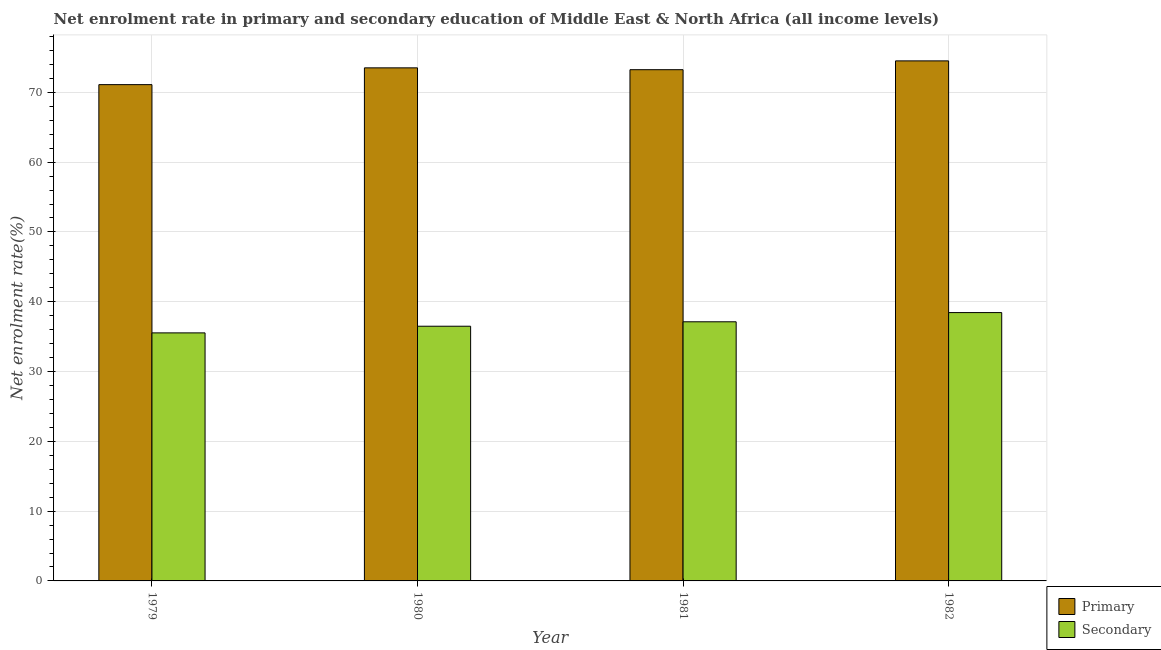How many groups of bars are there?
Make the answer very short. 4. Are the number of bars per tick equal to the number of legend labels?
Provide a succinct answer. Yes. In how many cases, is the number of bars for a given year not equal to the number of legend labels?
Offer a very short reply. 0. What is the enrollment rate in primary education in 1979?
Offer a terse response. 71.11. Across all years, what is the maximum enrollment rate in primary education?
Keep it short and to the point. 74.51. Across all years, what is the minimum enrollment rate in primary education?
Your response must be concise. 71.11. In which year was the enrollment rate in primary education minimum?
Keep it short and to the point. 1979. What is the total enrollment rate in secondary education in the graph?
Offer a very short reply. 147.6. What is the difference between the enrollment rate in primary education in 1979 and that in 1982?
Offer a very short reply. -3.4. What is the difference between the enrollment rate in secondary education in 1980 and the enrollment rate in primary education in 1982?
Ensure brevity in your answer.  -1.95. What is the average enrollment rate in primary education per year?
Give a very brief answer. 73.09. In how many years, is the enrollment rate in secondary education greater than 26 %?
Your response must be concise. 4. What is the ratio of the enrollment rate in secondary education in 1980 to that in 1981?
Make the answer very short. 0.98. What is the difference between the highest and the second highest enrollment rate in primary education?
Your response must be concise. 1. What is the difference between the highest and the lowest enrollment rate in secondary education?
Your answer should be compact. 2.91. What does the 2nd bar from the left in 1979 represents?
Offer a terse response. Secondary. What does the 1st bar from the right in 1979 represents?
Provide a short and direct response. Secondary. What is the difference between two consecutive major ticks on the Y-axis?
Keep it short and to the point. 10. How many legend labels are there?
Your answer should be compact. 2. How are the legend labels stacked?
Offer a very short reply. Vertical. What is the title of the graph?
Your response must be concise. Net enrolment rate in primary and secondary education of Middle East & North Africa (all income levels). What is the label or title of the Y-axis?
Make the answer very short. Net enrolment rate(%). What is the Net enrolment rate(%) in Primary in 1979?
Provide a short and direct response. 71.11. What is the Net enrolment rate(%) of Secondary in 1979?
Offer a very short reply. 35.54. What is the Net enrolment rate(%) of Primary in 1980?
Provide a succinct answer. 73.51. What is the Net enrolment rate(%) of Secondary in 1980?
Offer a terse response. 36.49. What is the Net enrolment rate(%) in Primary in 1981?
Keep it short and to the point. 73.25. What is the Net enrolment rate(%) of Secondary in 1981?
Your answer should be compact. 37.13. What is the Net enrolment rate(%) of Primary in 1982?
Your answer should be compact. 74.51. What is the Net enrolment rate(%) in Secondary in 1982?
Make the answer very short. 38.45. Across all years, what is the maximum Net enrolment rate(%) of Primary?
Keep it short and to the point. 74.51. Across all years, what is the maximum Net enrolment rate(%) of Secondary?
Provide a short and direct response. 38.45. Across all years, what is the minimum Net enrolment rate(%) in Primary?
Give a very brief answer. 71.11. Across all years, what is the minimum Net enrolment rate(%) in Secondary?
Your answer should be very brief. 35.54. What is the total Net enrolment rate(%) in Primary in the graph?
Make the answer very short. 292.37. What is the total Net enrolment rate(%) of Secondary in the graph?
Provide a short and direct response. 147.6. What is the difference between the Net enrolment rate(%) in Primary in 1979 and that in 1980?
Your response must be concise. -2.4. What is the difference between the Net enrolment rate(%) of Secondary in 1979 and that in 1980?
Provide a short and direct response. -0.95. What is the difference between the Net enrolment rate(%) in Primary in 1979 and that in 1981?
Your response must be concise. -2.14. What is the difference between the Net enrolment rate(%) in Secondary in 1979 and that in 1981?
Your answer should be very brief. -1.59. What is the difference between the Net enrolment rate(%) of Primary in 1979 and that in 1982?
Your answer should be compact. -3.4. What is the difference between the Net enrolment rate(%) of Secondary in 1979 and that in 1982?
Offer a terse response. -2.91. What is the difference between the Net enrolment rate(%) of Primary in 1980 and that in 1981?
Your answer should be very brief. 0.26. What is the difference between the Net enrolment rate(%) in Secondary in 1980 and that in 1981?
Make the answer very short. -0.64. What is the difference between the Net enrolment rate(%) of Primary in 1980 and that in 1982?
Offer a terse response. -1. What is the difference between the Net enrolment rate(%) of Secondary in 1980 and that in 1982?
Offer a terse response. -1.95. What is the difference between the Net enrolment rate(%) of Primary in 1981 and that in 1982?
Provide a short and direct response. -1.26. What is the difference between the Net enrolment rate(%) in Secondary in 1981 and that in 1982?
Offer a very short reply. -1.32. What is the difference between the Net enrolment rate(%) of Primary in 1979 and the Net enrolment rate(%) of Secondary in 1980?
Give a very brief answer. 34.61. What is the difference between the Net enrolment rate(%) in Primary in 1979 and the Net enrolment rate(%) in Secondary in 1981?
Your answer should be compact. 33.98. What is the difference between the Net enrolment rate(%) in Primary in 1979 and the Net enrolment rate(%) in Secondary in 1982?
Your response must be concise. 32.66. What is the difference between the Net enrolment rate(%) of Primary in 1980 and the Net enrolment rate(%) of Secondary in 1981?
Provide a succinct answer. 36.38. What is the difference between the Net enrolment rate(%) of Primary in 1980 and the Net enrolment rate(%) of Secondary in 1982?
Your response must be concise. 35.06. What is the difference between the Net enrolment rate(%) of Primary in 1981 and the Net enrolment rate(%) of Secondary in 1982?
Keep it short and to the point. 34.8. What is the average Net enrolment rate(%) of Primary per year?
Your answer should be very brief. 73.09. What is the average Net enrolment rate(%) in Secondary per year?
Provide a succinct answer. 36.9. In the year 1979, what is the difference between the Net enrolment rate(%) of Primary and Net enrolment rate(%) of Secondary?
Provide a succinct answer. 35.57. In the year 1980, what is the difference between the Net enrolment rate(%) of Primary and Net enrolment rate(%) of Secondary?
Ensure brevity in your answer.  37.02. In the year 1981, what is the difference between the Net enrolment rate(%) in Primary and Net enrolment rate(%) in Secondary?
Your answer should be compact. 36.12. In the year 1982, what is the difference between the Net enrolment rate(%) of Primary and Net enrolment rate(%) of Secondary?
Give a very brief answer. 36.06. What is the ratio of the Net enrolment rate(%) in Primary in 1979 to that in 1980?
Keep it short and to the point. 0.97. What is the ratio of the Net enrolment rate(%) in Secondary in 1979 to that in 1980?
Offer a very short reply. 0.97. What is the ratio of the Net enrolment rate(%) of Primary in 1979 to that in 1981?
Make the answer very short. 0.97. What is the ratio of the Net enrolment rate(%) of Secondary in 1979 to that in 1981?
Your response must be concise. 0.96. What is the ratio of the Net enrolment rate(%) of Primary in 1979 to that in 1982?
Give a very brief answer. 0.95. What is the ratio of the Net enrolment rate(%) of Secondary in 1979 to that in 1982?
Ensure brevity in your answer.  0.92. What is the ratio of the Net enrolment rate(%) in Secondary in 1980 to that in 1981?
Make the answer very short. 0.98. What is the ratio of the Net enrolment rate(%) of Primary in 1980 to that in 1982?
Your answer should be very brief. 0.99. What is the ratio of the Net enrolment rate(%) in Secondary in 1980 to that in 1982?
Keep it short and to the point. 0.95. What is the ratio of the Net enrolment rate(%) in Secondary in 1981 to that in 1982?
Offer a terse response. 0.97. What is the difference between the highest and the second highest Net enrolment rate(%) of Secondary?
Make the answer very short. 1.32. What is the difference between the highest and the lowest Net enrolment rate(%) in Primary?
Your answer should be very brief. 3.4. What is the difference between the highest and the lowest Net enrolment rate(%) in Secondary?
Your answer should be very brief. 2.91. 